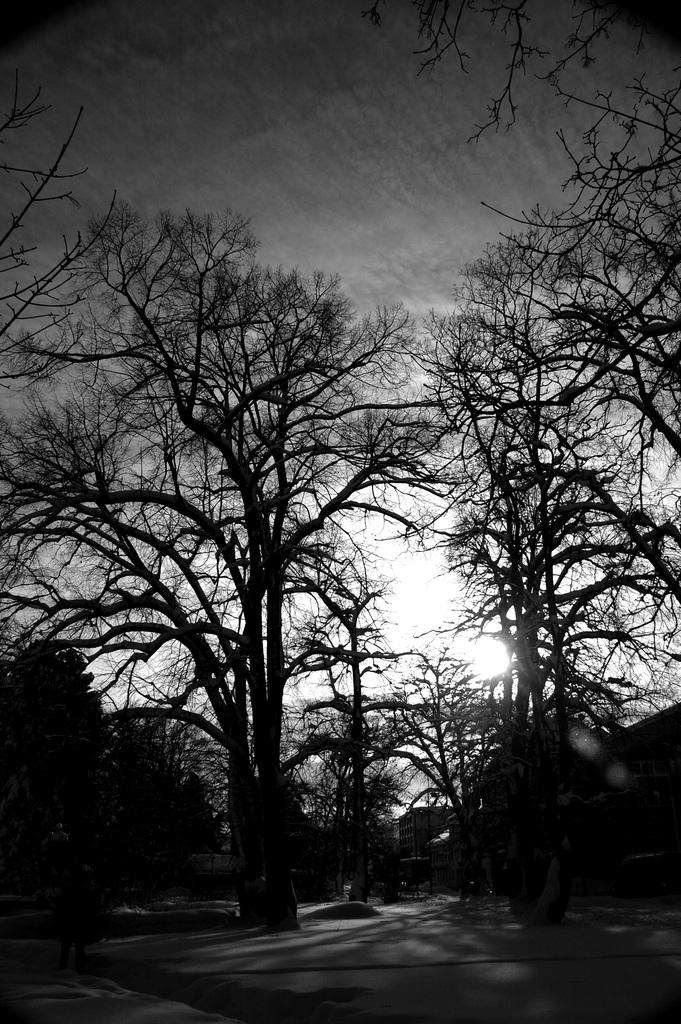What is the color scheme of the photograph in the image? The photograph in the image is black and white. What type of vegetation can be seen in the image? There are dry trees in the image. What can be seen in the background of the image? There is a sky visible in the background of the image. What type of noise can be heard coming from the hen in the image? There is no hen present in the image, so it is not possible to determine what noise, if any, might be heard. 